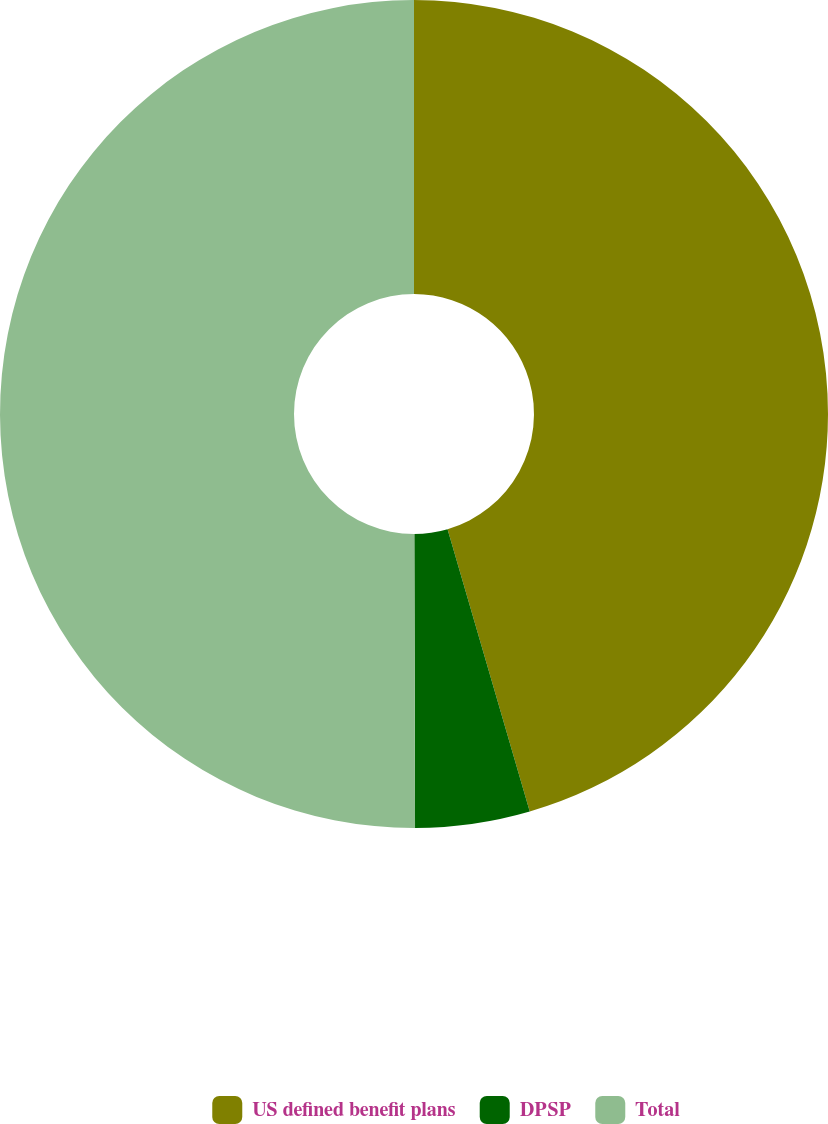<chart> <loc_0><loc_0><loc_500><loc_500><pie_chart><fcel>US defined benefit plans<fcel>DPSP<fcel>Total<nl><fcel>45.49%<fcel>4.47%<fcel>50.04%<nl></chart> 